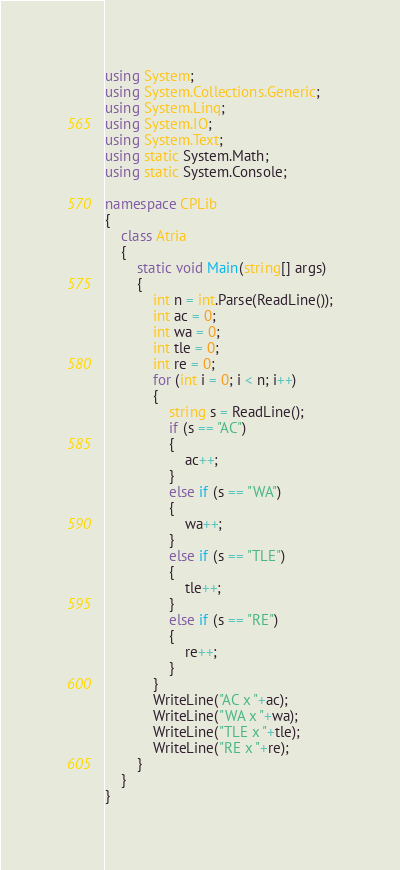<code> <loc_0><loc_0><loc_500><loc_500><_C#_>using System;
using System.Collections.Generic;
using System.Linq;
using System.IO;
using System.Text;
using static System.Math;
using static System.Console;

namespace CPLib
{
    class Atria
    {
        static void Main(string[] args)
        {
            int n = int.Parse(ReadLine());
            int ac = 0;
            int wa = 0;
            int tle = 0;
            int re = 0;
            for (int i = 0; i < n; i++)
            {
                string s = ReadLine();
                if (s == "AC")
                {
                    ac++;
                }
                else if (s == "WA")
                {
                    wa++;
                }
                else if (s == "TLE")
                {
                    tle++;
                }
                else if (s == "RE")
                {
                    re++;
                }
            }
            WriteLine("AC x "+ac);
            WriteLine("WA x "+wa);
            WriteLine("TLE x "+tle);
            WriteLine("RE x "+re);
        }
    }
}
</code> 